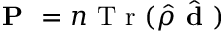Convert formula to latex. <formula><loc_0><loc_0><loc_500><loc_500>P = n T r ( \hat { \rho } \hat { d } )</formula> 